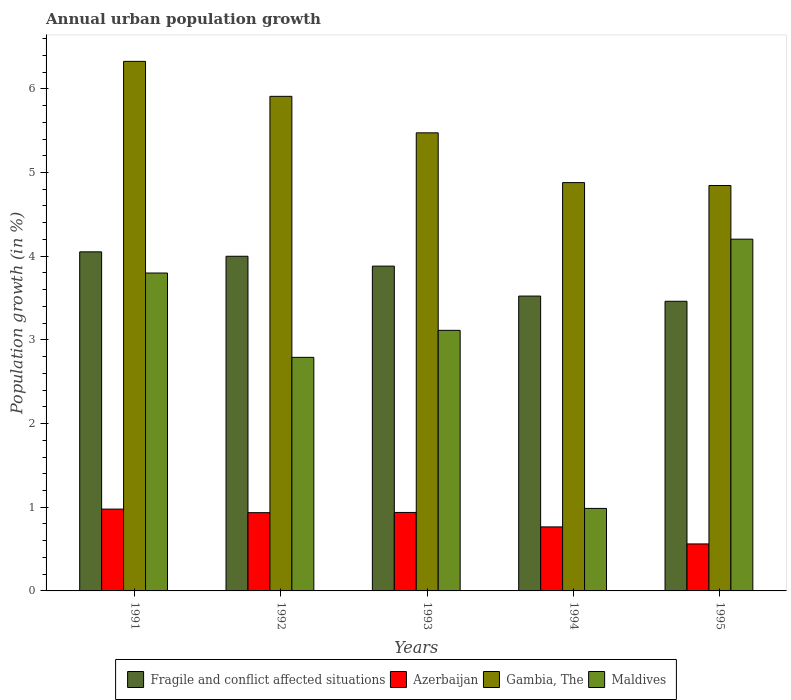How many different coloured bars are there?
Make the answer very short. 4. Are the number of bars per tick equal to the number of legend labels?
Provide a short and direct response. Yes. How many bars are there on the 4th tick from the left?
Offer a very short reply. 4. How many bars are there on the 1st tick from the right?
Keep it short and to the point. 4. What is the percentage of urban population growth in Maldives in 1992?
Offer a very short reply. 2.79. Across all years, what is the maximum percentage of urban population growth in Azerbaijan?
Offer a very short reply. 0.98. Across all years, what is the minimum percentage of urban population growth in Fragile and conflict affected situations?
Offer a terse response. 3.46. In which year was the percentage of urban population growth in Gambia, The minimum?
Your answer should be compact. 1995. What is the total percentage of urban population growth in Gambia, The in the graph?
Offer a very short reply. 27.43. What is the difference between the percentage of urban population growth in Maldives in 1991 and that in 1995?
Your answer should be very brief. -0.4. What is the difference between the percentage of urban population growth in Maldives in 1992 and the percentage of urban population growth in Gambia, The in 1993?
Give a very brief answer. -2.68. What is the average percentage of urban population growth in Azerbaijan per year?
Ensure brevity in your answer.  0.84. In the year 1995, what is the difference between the percentage of urban population growth in Gambia, The and percentage of urban population growth in Azerbaijan?
Keep it short and to the point. 4.28. In how many years, is the percentage of urban population growth in Azerbaijan greater than 2.4 %?
Offer a very short reply. 0. What is the ratio of the percentage of urban population growth in Azerbaijan in 1992 to that in 1994?
Ensure brevity in your answer.  1.22. Is the difference between the percentage of urban population growth in Gambia, The in 1994 and 1995 greater than the difference between the percentage of urban population growth in Azerbaijan in 1994 and 1995?
Offer a very short reply. No. What is the difference between the highest and the second highest percentage of urban population growth in Azerbaijan?
Ensure brevity in your answer.  0.04. What is the difference between the highest and the lowest percentage of urban population growth in Gambia, The?
Ensure brevity in your answer.  1.48. Is the sum of the percentage of urban population growth in Gambia, The in 1992 and 1994 greater than the maximum percentage of urban population growth in Fragile and conflict affected situations across all years?
Offer a very short reply. Yes. What does the 2nd bar from the left in 1994 represents?
Offer a terse response. Azerbaijan. What does the 3rd bar from the right in 1993 represents?
Your answer should be very brief. Azerbaijan. How many bars are there?
Your response must be concise. 20. What is the difference between two consecutive major ticks on the Y-axis?
Your answer should be compact. 1. Does the graph contain grids?
Offer a very short reply. No. Where does the legend appear in the graph?
Give a very brief answer. Bottom center. How are the legend labels stacked?
Ensure brevity in your answer.  Horizontal. What is the title of the graph?
Give a very brief answer. Annual urban population growth. Does "San Marino" appear as one of the legend labels in the graph?
Provide a succinct answer. No. What is the label or title of the X-axis?
Give a very brief answer. Years. What is the label or title of the Y-axis?
Ensure brevity in your answer.  Population growth (in %). What is the Population growth (in %) of Fragile and conflict affected situations in 1991?
Your response must be concise. 4.05. What is the Population growth (in %) of Azerbaijan in 1991?
Your response must be concise. 0.98. What is the Population growth (in %) in Gambia, The in 1991?
Offer a terse response. 6.33. What is the Population growth (in %) in Maldives in 1991?
Ensure brevity in your answer.  3.8. What is the Population growth (in %) of Fragile and conflict affected situations in 1992?
Provide a short and direct response. 4. What is the Population growth (in %) of Azerbaijan in 1992?
Keep it short and to the point. 0.94. What is the Population growth (in %) in Gambia, The in 1992?
Offer a very short reply. 5.91. What is the Population growth (in %) in Maldives in 1992?
Your response must be concise. 2.79. What is the Population growth (in %) of Fragile and conflict affected situations in 1993?
Your answer should be very brief. 3.88. What is the Population growth (in %) of Azerbaijan in 1993?
Your response must be concise. 0.94. What is the Population growth (in %) of Gambia, The in 1993?
Give a very brief answer. 5.47. What is the Population growth (in %) of Maldives in 1993?
Give a very brief answer. 3.11. What is the Population growth (in %) in Fragile and conflict affected situations in 1994?
Ensure brevity in your answer.  3.52. What is the Population growth (in %) of Azerbaijan in 1994?
Make the answer very short. 0.77. What is the Population growth (in %) in Gambia, The in 1994?
Provide a succinct answer. 4.88. What is the Population growth (in %) of Maldives in 1994?
Your answer should be very brief. 0.99. What is the Population growth (in %) in Fragile and conflict affected situations in 1995?
Ensure brevity in your answer.  3.46. What is the Population growth (in %) of Azerbaijan in 1995?
Offer a terse response. 0.56. What is the Population growth (in %) of Gambia, The in 1995?
Provide a short and direct response. 4.84. What is the Population growth (in %) in Maldives in 1995?
Your response must be concise. 4.2. Across all years, what is the maximum Population growth (in %) of Fragile and conflict affected situations?
Provide a short and direct response. 4.05. Across all years, what is the maximum Population growth (in %) in Azerbaijan?
Your response must be concise. 0.98. Across all years, what is the maximum Population growth (in %) in Gambia, The?
Provide a succinct answer. 6.33. Across all years, what is the maximum Population growth (in %) in Maldives?
Your response must be concise. 4.2. Across all years, what is the minimum Population growth (in %) of Fragile and conflict affected situations?
Make the answer very short. 3.46. Across all years, what is the minimum Population growth (in %) of Azerbaijan?
Keep it short and to the point. 0.56. Across all years, what is the minimum Population growth (in %) in Gambia, The?
Your answer should be very brief. 4.84. Across all years, what is the minimum Population growth (in %) in Maldives?
Provide a succinct answer. 0.99. What is the total Population growth (in %) in Fragile and conflict affected situations in the graph?
Your answer should be compact. 18.92. What is the total Population growth (in %) of Azerbaijan in the graph?
Your answer should be compact. 4.18. What is the total Population growth (in %) of Gambia, The in the graph?
Offer a very short reply. 27.43. What is the total Population growth (in %) in Maldives in the graph?
Offer a very short reply. 14.89. What is the difference between the Population growth (in %) of Fragile and conflict affected situations in 1991 and that in 1992?
Ensure brevity in your answer.  0.05. What is the difference between the Population growth (in %) of Azerbaijan in 1991 and that in 1992?
Offer a very short reply. 0.04. What is the difference between the Population growth (in %) of Gambia, The in 1991 and that in 1992?
Offer a very short reply. 0.42. What is the difference between the Population growth (in %) in Fragile and conflict affected situations in 1991 and that in 1993?
Provide a short and direct response. 0.17. What is the difference between the Population growth (in %) of Azerbaijan in 1991 and that in 1993?
Your answer should be compact. 0.04. What is the difference between the Population growth (in %) in Gambia, The in 1991 and that in 1993?
Provide a short and direct response. 0.85. What is the difference between the Population growth (in %) of Maldives in 1991 and that in 1993?
Your answer should be compact. 0.68. What is the difference between the Population growth (in %) of Fragile and conflict affected situations in 1991 and that in 1994?
Ensure brevity in your answer.  0.53. What is the difference between the Population growth (in %) of Azerbaijan in 1991 and that in 1994?
Offer a terse response. 0.21. What is the difference between the Population growth (in %) in Gambia, The in 1991 and that in 1994?
Your answer should be very brief. 1.45. What is the difference between the Population growth (in %) of Maldives in 1991 and that in 1994?
Your answer should be compact. 2.81. What is the difference between the Population growth (in %) of Fragile and conflict affected situations in 1991 and that in 1995?
Your answer should be very brief. 0.59. What is the difference between the Population growth (in %) in Azerbaijan in 1991 and that in 1995?
Your answer should be compact. 0.42. What is the difference between the Population growth (in %) of Gambia, The in 1991 and that in 1995?
Your response must be concise. 1.48. What is the difference between the Population growth (in %) of Maldives in 1991 and that in 1995?
Offer a very short reply. -0.4. What is the difference between the Population growth (in %) of Fragile and conflict affected situations in 1992 and that in 1993?
Keep it short and to the point. 0.12. What is the difference between the Population growth (in %) in Azerbaijan in 1992 and that in 1993?
Make the answer very short. -0. What is the difference between the Population growth (in %) in Gambia, The in 1992 and that in 1993?
Give a very brief answer. 0.44. What is the difference between the Population growth (in %) in Maldives in 1992 and that in 1993?
Give a very brief answer. -0.32. What is the difference between the Population growth (in %) of Fragile and conflict affected situations in 1992 and that in 1994?
Make the answer very short. 0.48. What is the difference between the Population growth (in %) in Azerbaijan in 1992 and that in 1994?
Make the answer very short. 0.17. What is the difference between the Population growth (in %) of Gambia, The in 1992 and that in 1994?
Provide a succinct answer. 1.03. What is the difference between the Population growth (in %) of Maldives in 1992 and that in 1994?
Make the answer very short. 1.8. What is the difference between the Population growth (in %) of Fragile and conflict affected situations in 1992 and that in 1995?
Offer a very short reply. 0.54. What is the difference between the Population growth (in %) in Azerbaijan in 1992 and that in 1995?
Make the answer very short. 0.37. What is the difference between the Population growth (in %) of Gambia, The in 1992 and that in 1995?
Provide a succinct answer. 1.07. What is the difference between the Population growth (in %) in Maldives in 1992 and that in 1995?
Make the answer very short. -1.41. What is the difference between the Population growth (in %) of Fragile and conflict affected situations in 1993 and that in 1994?
Give a very brief answer. 0.36. What is the difference between the Population growth (in %) in Azerbaijan in 1993 and that in 1994?
Your answer should be very brief. 0.17. What is the difference between the Population growth (in %) in Gambia, The in 1993 and that in 1994?
Your response must be concise. 0.59. What is the difference between the Population growth (in %) of Maldives in 1993 and that in 1994?
Keep it short and to the point. 2.13. What is the difference between the Population growth (in %) of Fragile and conflict affected situations in 1993 and that in 1995?
Your answer should be very brief. 0.42. What is the difference between the Population growth (in %) of Azerbaijan in 1993 and that in 1995?
Keep it short and to the point. 0.38. What is the difference between the Population growth (in %) in Gambia, The in 1993 and that in 1995?
Keep it short and to the point. 0.63. What is the difference between the Population growth (in %) of Maldives in 1993 and that in 1995?
Offer a very short reply. -1.09. What is the difference between the Population growth (in %) in Fragile and conflict affected situations in 1994 and that in 1995?
Provide a short and direct response. 0.06. What is the difference between the Population growth (in %) in Azerbaijan in 1994 and that in 1995?
Your answer should be very brief. 0.2. What is the difference between the Population growth (in %) of Gambia, The in 1994 and that in 1995?
Offer a very short reply. 0.03. What is the difference between the Population growth (in %) of Maldives in 1994 and that in 1995?
Your answer should be compact. -3.22. What is the difference between the Population growth (in %) of Fragile and conflict affected situations in 1991 and the Population growth (in %) of Azerbaijan in 1992?
Make the answer very short. 3.12. What is the difference between the Population growth (in %) in Fragile and conflict affected situations in 1991 and the Population growth (in %) in Gambia, The in 1992?
Keep it short and to the point. -1.86. What is the difference between the Population growth (in %) of Fragile and conflict affected situations in 1991 and the Population growth (in %) of Maldives in 1992?
Your response must be concise. 1.26. What is the difference between the Population growth (in %) of Azerbaijan in 1991 and the Population growth (in %) of Gambia, The in 1992?
Make the answer very short. -4.93. What is the difference between the Population growth (in %) of Azerbaijan in 1991 and the Population growth (in %) of Maldives in 1992?
Offer a very short reply. -1.81. What is the difference between the Population growth (in %) of Gambia, The in 1991 and the Population growth (in %) of Maldives in 1992?
Your response must be concise. 3.54. What is the difference between the Population growth (in %) in Fragile and conflict affected situations in 1991 and the Population growth (in %) in Azerbaijan in 1993?
Your response must be concise. 3.11. What is the difference between the Population growth (in %) of Fragile and conflict affected situations in 1991 and the Population growth (in %) of Gambia, The in 1993?
Your response must be concise. -1.42. What is the difference between the Population growth (in %) of Fragile and conflict affected situations in 1991 and the Population growth (in %) of Maldives in 1993?
Ensure brevity in your answer.  0.94. What is the difference between the Population growth (in %) in Azerbaijan in 1991 and the Population growth (in %) in Gambia, The in 1993?
Offer a very short reply. -4.5. What is the difference between the Population growth (in %) of Azerbaijan in 1991 and the Population growth (in %) of Maldives in 1993?
Your answer should be compact. -2.14. What is the difference between the Population growth (in %) in Gambia, The in 1991 and the Population growth (in %) in Maldives in 1993?
Provide a short and direct response. 3.21. What is the difference between the Population growth (in %) in Fragile and conflict affected situations in 1991 and the Population growth (in %) in Azerbaijan in 1994?
Your answer should be very brief. 3.29. What is the difference between the Population growth (in %) of Fragile and conflict affected situations in 1991 and the Population growth (in %) of Gambia, The in 1994?
Make the answer very short. -0.83. What is the difference between the Population growth (in %) of Fragile and conflict affected situations in 1991 and the Population growth (in %) of Maldives in 1994?
Provide a short and direct response. 3.07. What is the difference between the Population growth (in %) of Azerbaijan in 1991 and the Population growth (in %) of Gambia, The in 1994?
Give a very brief answer. -3.9. What is the difference between the Population growth (in %) of Azerbaijan in 1991 and the Population growth (in %) of Maldives in 1994?
Ensure brevity in your answer.  -0.01. What is the difference between the Population growth (in %) in Gambia, The in 1991 and the Population growth (in %) in Maldives in 1994?
Provide a short and direct response. 5.34. What is the difference between the Population growth (in %) of Fragile and conflict affected situations in 1991 and the Population growth (in %) of Azerbaijan in 1995?
Your answer should be very brief. 3.49. What is the difference between the Population growth (in %) of Fragile and conflict affected situations in 1991 and the Population growth (in %) of Gambia, The in 1995?
Your answer should be very brief. -0.79. What is the difference between the Population growth (in %) of Fragile and conflict affected situations in 1991 and the Population growth (in %) of Maldives in 1995?
Make the answer very short. -0.15. What is the difference between the Population growth (in %) in Azerbaijan in 1991 and the Population growth (in %) in Gambia, The in 1995?
Make the answer very short. -3.87. What is the difference between the Population growth (in %) of Azerbaijan in 1991 and the Population growth (in %) of Maldives in 1995?
Offer a very short reply. -3.23. What is the difference between the Population growth (in %) in Gambia, The in 1991 and the Population growth (in %) in Maldives in 1995?
Offer a terse response. 2.12. What is the difference between the Population growth (in %) in Fragile and conflict affected situations in 1992 and the Population growth (in %) in Azerbaijan in 1993?
Give a very brief answer. 3.06. What is the difference between the Population growth (in %) of Fragile and conflict affected situations in 1992 and the Population growth (in %) of Gambia, The in 1993?
Your response must be concise. -1.47. What is the difference between the Population growth (in %) in Fragile and conflict affected situations in 1992 and the Population growth (in %) in Maldives in 1993?
Your answer should be compact. 0.89. What is the difference between the Population growth (in %) of Azerbaijan in 1992 and the Population growth (in %) of Gambia, The in 1993?
Provide a succinct answer. -4.54. What is the difference between the Population growth (in %) of Azerbaijan in 1992 and the Population growth (in %) of Maldives in 1993?
Provide a short and direct response. -2.18. What is the difference between the Population growth (in %) in Gambia, The in 1992 and the Population growth (in %) in Maldives in 1993?
Your response must be concise. 2.8. What is the difference between the Population growth (in %) of Fragile and conflict affected situations in 1992 and the Population growth (in %) of Azerbaijan in 1994?
Offer a terse response. 3.23. What is the difference between the Population growth (in %) of Fragile and conflict affected situations in 1992 and the Population growth (in %) of Gambia, The in 1994?
Give a very brief answer. -0.88. What is the difference between the Population growth (in %) in Fragile and conflict affected situations in 1992 and the Population growth (in %) in Maldives in 1994?
Provide a short and direct response. 3.01. What is the difference between the Population growth (in %) in Azerbaijan in 1992 and the Population growth (in %) in Gambia, The in 1994?
Give a very brief answer. -3.94. What is the difference between the Population growth (in %) of Azerbaijan in 1992 and the Population growth (in %) of Maldives in 1994?
Offer a terse response. -0.05. What is the difference between the Population growth (in %) in Gambia, The in 1992 and the Population growth (in %) in Maldives in 1994?
Offer a terse response. 4.92. What is the difference between the Population growth (in %) of Fragile and conflict affected situations in 1992 and the Population growth (in %) of Azerbaijan in 1995?
Keep it short and to the point. 3.44. What is the difference between the Population growth (in %) in Fragile and conflict affected situations in 1992 and the Population growth (in %) in Gambia, The in 1995?
Ensure brevity in your answer.  -0.85. What is the difference between the Population growth (in %) of Fragile and conflict affected situations in 1992 and the Population growth (in %) of Maldives in 1995?
Your answer should be very brief. -0.2. What is the difference between the Population growth (in %) of Azerbaijan in 1992 and the Population growth (in %) of Gambia, The in 1995?
Your answer should be very brief. -3.91. What is the difference between the Population growth (in %) of Azerbaijan in 1992 and the Population growth (in %) of Maldives in 1995?
Offer a terse response. -3.27. What is the difference between the Population growth (in %) of Gambia, The in 1992 and the Population growth (in %) of Maldives in 1995?
Your response must be concise. 1.71. What is the difference between the Population growth (in %) of Fragile and conflict affected situations in 1993 and the Population growth (in %) of Azerbaijan in 1994?
Offer a terse response. 3.12. What is the difference between the Population growth (in %) in Fragile and conflict affected situations in 1993 and the Population growth (in %) in Gambia, The in 1994?
Your answer should be very brief. -1. What is the difference between the Population growth (in %) in Fragile and conflict affected situations in 1993 and the Population growth (in %) in Maldives in 1994?
Ensure brevity in your answer.  2.9. What is the difference between the Population growth (in %) in Azerbaijan in 1993 and the Population growth (in %) in Gambia, The in 1994?
Ensure brevity in your answer.  -3.94. What is the difference between the Population growth (in %) of Azerbaijan in 1993 and the Population growth (in %) of Maldives in 1994?
Your answer should be compact. -0.05. What is the difference between the Population growth (in %) of Gambia, The in 1993 and the Population growth (in %) of Maldives in 1994?
Offer a very short reply. 4.49. What is the difference between the Population growth (in %) of Fragile and conflict affected situations in 1993 and the Population growth (in %) of Azerbaijan in 1995?
Make the answer very short. 3.32. What is the difference between the Population growth (in %) in Fragile and conflict affected situations in 1993 and the Population growth (in %) in Gambia, The in 1995?
Offer a very short reply. -0.96. What is the difference between the Population growth (in %) of Fragile and conflict affected situations in 1993 and the Population growth (in %) of Maldives in 1995?
Provide a short and direct response. -0.32. What is the difference between the Population growth (in %) in Azerbaijan in 1993 and the Population growth (in %) in Gambia, The in 1995?
Make the answer very short. -3.91. What is the difference between the Population growth (in %) in Azerbaijan in 1993 and the Population growth (in %) in Maldives in 1995?
Provide a succinct answer. -3.27. What is the difference between the Population growth (in %) in Gambia, The in 1993 and the Population growth (in %) in Maldives in 1995?
Ensure brevity in your answer.  1.27. What is the difference between the Population growth (in %) of Fragile and conflict affected situations in 1994 and the Population growth (in %) of Azerbaijan in 1995?
Offer a very short reply. 2.96. What is the difference between the Population growth (in %) of Fragile and conflict affected situations in 1994 and the Population growth (in %) of Gambia, The in 1995?
Keep it short and to the point. -1.32. What is the difference between the Population growth (in %) in Fragile and conflict affected situations in 1994 and the Population growth (in %) in Maldives in 1995?
Your answer should be compact. -0.68. What is the difference between the Population growth (in %) in Azerbaijan in 1994 and the Population growth (in %) in Gambia, The in 1995?
Make the answer very short. -4.08. What is the difference between the Population growth (in %) of Azerbaijan in 1994 and the Population growth (in %) of Maldives in 1995?
Make the answer very short. -3.44. What is the difference between the Population growth (in %) in Gambia, The in 1994 and the Population growth (in %) in Maldives in 1995?
Your response must be concise. 0.68. What is the average Population growth (in %) of Fragile and conflict affected situations per year?
Your answer should be compact. 3.78. What is the average Population growth (in %) in Azerbaijan per year?
Keep it short and to the point. 0.84. What is the average Population growth (in %) in Gambia, The per year?
Give a very brief answer. 5.49. What is the average Population growth (in %) in Maldives per year?
Offer a terse response. 2.98. In the year 1991, what is the difference between the Population growth (in %) in Fragile and conflict affected situations and Population growth (in %) in Azerbaijan?
Provide a succinct answer. 3.07. In the year 1991, what is the difference between the Population growth (in %) in Fragile and conflict affected situations and Population growth (in %) in Gambia, The?
Offer a terse response. -2.28. In the year 1991, what is the difference between the Population growth (in %) in Fragile and conflict affected situations and Population growth (in %) in Maldives?
Provide a short and direct response. 0.25. In the year 1991, what is the difference between the Population growth (in %) of Azerbaijan and Population growth (in %) of Gambia, The?
Offer a terse response. -5.35. In the year 1991, what is the difference between the Population growth (in %) of Azerbaijan and Population growth (in %) of Maldives?
Offer a terse response. -2.82. In the year 1991, what is the difference between the Population growth (in %) of Gambia, The and Population growth (in %) of Maldives?
Offer a very short reply. 2.53. In the year 1992, what is the difference between the Population growth (in %) in Fragile and conflict affected situations and Population growth (in %) in Azerbaijan?
Offer a very short reply. 3.06. In the year 1992, what is the difference between the Population growth (in %) of Fragile and conflict affected situations and Population growth (in %) of Gambia, The?
Your answer should be compact. -1.91. In the year 1992, what is the difference between the Population growth (in %) in Fragile and conflict affected situations and Population growth (in %) in Maldives?
Your answer should be very brief. 1.21. In the year 1992, what is the difference between the Population growth (in %) of Azerbaijan and Population growth (in %) of Gambia, The?
Give a very brief answer. -4.97. In the year 1992, what is the difference between the Population growth (in %) of Azerbaijan and Population growth (in %) of Maldives?
Give a very brief answer. -1.86. In the year 1992, what is the difference between the Population growth (in %) in Gambia, The and Population growth (in %) in Maldives?
Offer a very short reply. 3.12. In the year 1993, what is the difference between the Population growth (in %) in Fragile and conflict affected situations and Population growth (in %) in Azerbaijan?
Make the answer very short. 2.94. In the year 1993, what is the difference between the Population growth (in %) in Fragile and conflict affected situations and Population growth (in %) in Gambia, The?
Make the answer very short. -1.59. In the year 1993, what is the difference between the Population growth (in %) in Fragile and conflict affected situations and Population growth (in %) in Maldives?
Ensure brevity in your answer.  0.77. In the year 1993, what is the difference between the Population growth (in %) of Azerbaijan and Population growth (in %) of Gambia, The?
Your answer should be very brief. -4.54. In the year 1993, what is the difference between the Population growth (in %) in Azerbaijan and Population growth (in %) in Maldives?
Keep it short and to the point. -2.18. In the year 1993, what is the difference between the Population growth (in %) of Gambia, The and Population growth (in %) of Maldives?
Offer a terse response. 2.36. In the year 1994, what is the difference between the Population growth (in %) in Fragile and conflict affected situations and Population growth (in %) in Azerbaijan?
Give a very brief answer. 2.76. In the year 1994, what is the difference between the Population growth (in %) in Fragile and conflict affected situations and Population growth (in %) in Gambia, The?
Provide a succinct answer. -1.36. In the year 1994, what is the difference between the Population growth (in %) of Fragile and conflict affected situations and Population growth (in %) of Maldives?
Provide a short and direct response. 2.54. In the year 1994, what is the difference between the Population growth (in %) of Azerbaijan and Population growth (in %) of Gambia, The?
Your answer should be very brief. -4.11. In the year 1994, what is the difference between the Population growth (in %) in Azerbaijan and Population growth (in %) in Maldives?
Provide a short and direct response. -0.22. In the year 1994, what is the difference between the Population growth (in %) of Gambia, The and Population growth (in %) of Maldives?
Keep it short and to the point. 3.89. In the year 1995, what is the difference between the Population growth (in %) in Fragile and conflict affected situations and Population growth (in %) in Azerbaijan?
Provide a short and direct response. 2.9. In the year 1995, what is the difference between the Population growth (in %) of Fragile and conflict affected situations and Population growth (in %) of Gambia, The?
Keep it short and to the point. -1.38. In the year 1995, what is the difference between the Population growth (in %) of Fragile and conflict affected situations and Population growth (in %) of Maldives?
Give a very brief answer. -0.74. In the year 1995, what is the difference between the Population growth (in %) in Azerbaijan and Population growth (in %) in Gambia, The?
Make the answer very short. -4.28. In the year 1995, what is the difference between the Population growth (in %) of Azerbaijan and Population growth (in %) of Maldives?
Provide a short and direct response. -3.64. In the year 1995, what is the difference between the Population growth (in %) of Gambia, The and Population growth (in %) of Maldives?
Your response must be concise. 0.64. What is the ratio of the Population growth (in %) of Fragile and conflict affected situations in 1991 to that in 1992?
Give a very brief answer. 1.01. What is the ratio of the Population growth (in %) of Azerbaijan in 1991 to that in 1992?
Offer a terse response. 1.05. What is the ratio of the Population growth (in %) of Gambia, The in 1991 to that in 1992?
Your answer should be compact. 1.07. What is the ratio of the Population growth (in %) of Maldives in 1991 to that in 1992?
Provide a succinct answer. 1.36. What is the ratio of the Population growth (in %) of Fragile and conflict affected situations in 1991 to that in 1993?
Make the answer very short. 1.04. What is the ratio of the Population growth (in %) in Azerbaijan in 1991 to that in 1993?
Offer a very short reply. 1.04. What is the ratio of the Population growth (in %) in Gambia, The in 1991 to that in 1993?
Provide a succinct answer. 1.16. What is the ratio of the Population growth (in %) of Maldives in 1991 to that in 1993?
Make the answer very short. 1.22. What is the ratio of the Population growth (in %) of Fragile and conflict affected situations in 1991 to that in 1994?
Keep it short and to the point. 1.15. What is the ratio of the Population growth (in %) in Azerbaijan in 1991 to that in 1994?
Your response must be concise. 1.28. What is the ratio of the Population growth (in %) in Gambia, The in 1991 to that in 1994?
Your answer should be very brief. 1.3. What is the ratio of the Population growth (in %) in Maldives in 1991 to that in 1994?
Your answer should be very brief. 3.85. What is the ratio of the Population growth (in %) of Fragile and conflict affected situations in 1991 to that in 1995?
Keep it short and to the point. 1.17. What is the ratio of the Population growth (in %) in Azerbaijan in 1991 to that in 1995?
Offer a terse response. 1.74. What is the ratio of the Population growth (in %) of Gambia, The in 1991 to that in 1995?
Offer a terse response. 1.31. What is the ratio of the Population growth (in %) of Maldives in 1991 to that in 1995?
Provide a short and direct response. 0.9. What is the ratio of the Population growth (in %) of Fragile and conflict affected situations in 1992 to that in 1993?
Your response must be concise. 1.03. What is the ratio of the Population growth (in %) in Gambia, The in 1992 to that in 1993?
Keep it short and to the point. 1.08. What is the ratio of the Population growth (in %) of Maldives in 1992 to that in 1993?
Your response must be concise. 0.9. What is the ratio of the Population growth (in %) of Fragile and conflict affected situations in 1992 to that in 1994?
Offer a terse response. 1.14. What is the ratio of the Population growth (in %) of Azerbaijan in 1992 to that in 1994?
Offer a very short reply. 1.22. What is the ratio of the Population growth (in %) in Gambia, The in 1992 to that in 1994?
Your answer should be compact. 1.21. What is the ratio of the Population growth (in %) in Maldives in 1992 to that in 1994?
Make the answer very short. 2.83. What is the ratio of the Population growth (in %) in Fragile and conflict affected situations in 1992 to that in 1995?
Your response must be concise. 1.16. What is the ratio of the Population growth (in %) of Azerbaijan in 1992 to that in 1995?
Offer a terse response. 1.67. What is the ratio of the Population growth (in %) in Gambia, The in 1992 to that in 1995?
Make the answer very short. 1.22. What is the ratio of the Population growth (in %) of Maldives in 1992 to that in 1995?
Ensure brevity in your answer.  0.66. What is the ratio of the Population growth (in %) in Fragile and conflict affected situations in 1993 to that in 1994?
Offer a terse response. 1.1. What is the ratio of the Population growth (in %) of Azerbaijan in 1993 to that in 1994?
Offer a very short reply. 1.23. What is the ratio of the Population growth (in %) in Gambia, The in 1993 to that in 1994?
Give a very brief answer. 1.12. What is the ratio of the Population growth (in %) of Maldives in 1993 to that in 1994?
Your response must be concise. 3.16. What is the ratio of the Population growth (in %) in Fragile and conflict affected situations in 1993 to that in 1995?
Provide a short and direct response. 1.12. What is the ratio of the Population growth (in %) of Azerbaijan in 1993 to that in 1995?
Your answer should be compact. 1.67. What is the ratio of the Population growth (in %) in Gambia, The in 1993 to that in 1995?
Your answer should be compact. 1.13. What is the ratio of the Population growth (in %) in Maldives in 1993 to that in 1995?
Offer a terse response. 0.74. What is the ratio of the Population growth (in %) in Fragile and conflict affected situations in 1994 to that in 1995?
Your answer should be compact. 1.02. What is the ratio of the Population growth (in %) in Azerbaijan in 1994 to that in 1995?
Keep it short and to the point. 1.36. What is the ratio of the Population growth (in %) of Maldives in 1994 to that in 1995?
Offer a very short reply. 0.23. What is the difference between the highest and the second highest Population growth (in %) of Fragile and conflict affected situations?
Ensure brevity in your answer.  0.05. What is the difference between the highest and the second highest Population growth (in %) in Azerbaijan?
Offer a terse response. 0.04. What is the difference between the highest and the second highest Population growth (in %) of Gambia, The?
Keep it short and to the point. 0.42. What is the difference between the highest and the second highest Population growth (in %) in Maldives?
Give a very brief answer. 0.4. What is the difference between the highest and the lowest Population growth (in %) of Fragile and conflict affected situations?
Offer a terse response. 0.59. What is the difference between the highest and the lowest Population growth (in %) in Azerbaijan?
Give a very brief answer. 0.42. What is the difference between the highest and the lowest Population growth (in %) in Gambia, The?
Provide a succinct answer. 1.48. What is the difference between the highest and the lowest Population growth (in %) of Maldives?
Your answer should be compact. 3.22. 